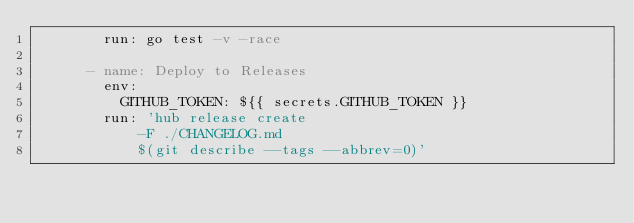<code> <loc_0><loc_0><loc_500><loc_500><_YAML_>        run: go test -v -race
        
      - name: Deploy to Releases
        env:
          GITHUB_TOKEN: ${{ secrets.GITHUB_TOKEN }}
        run: 'hub release create
            -F ./CHANGELOG.md
            $(git describe --tags --abbrev=0)'</code> 